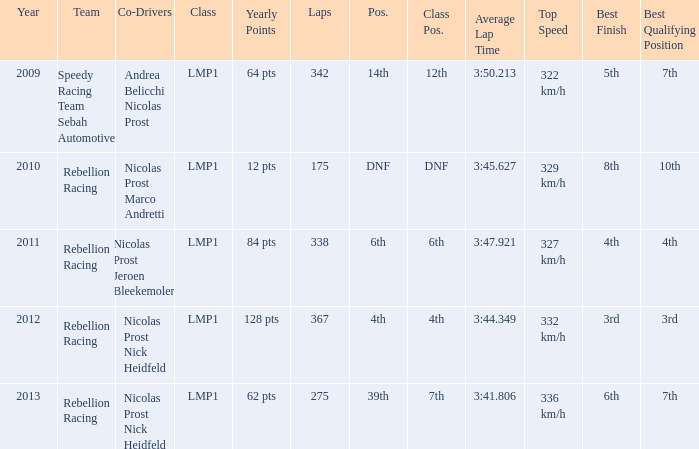What is Class Pos., when Year is before 2013, and when Laps is greater than 175? 12th, 6th, 4th. 